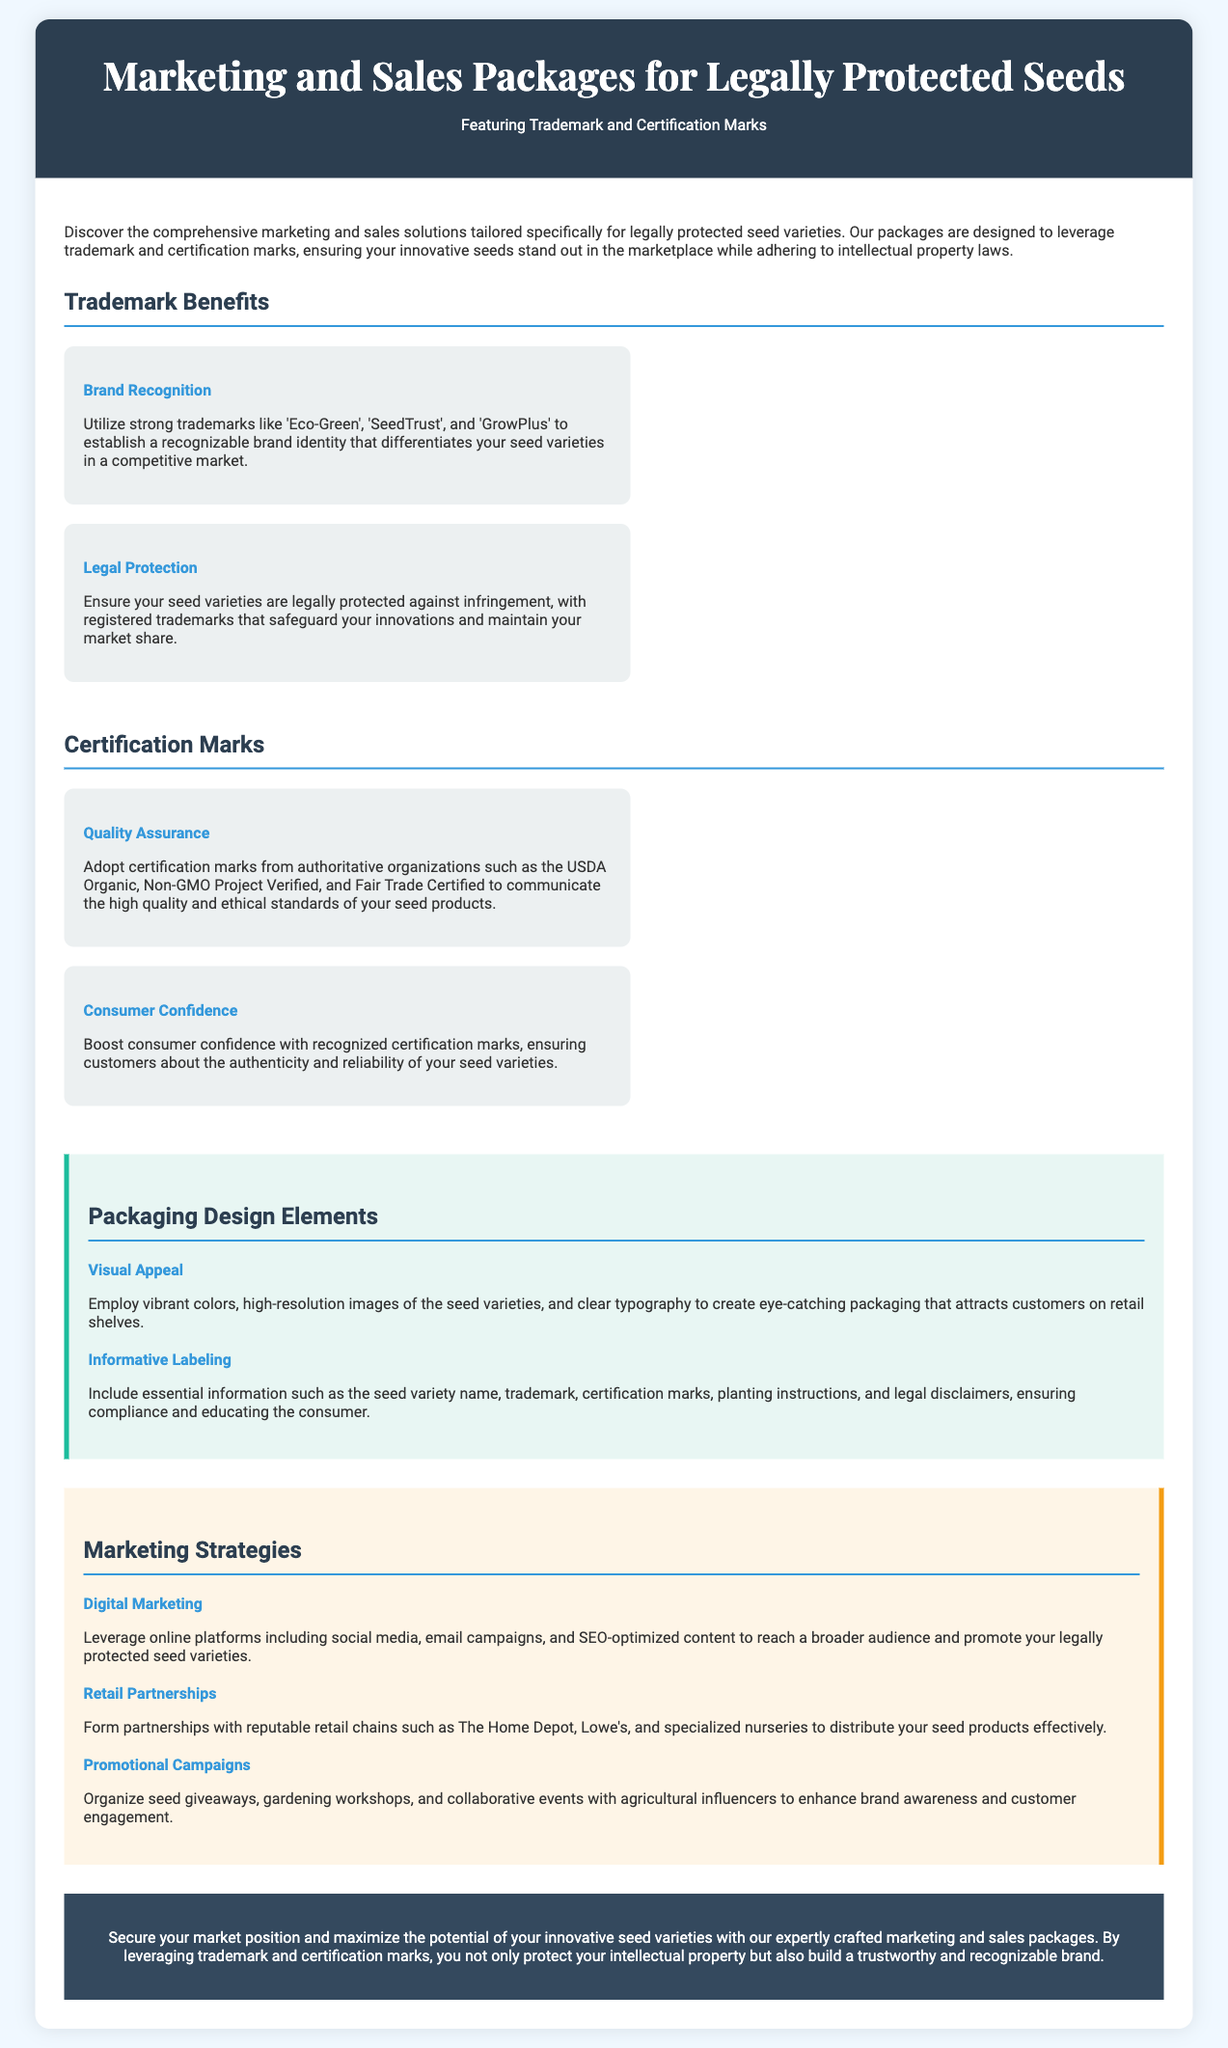What is the title of the document? The title of the document is presented in the header section, introducing the core topic of the document.
Answer: Marketing and Sales Packages for Legally Protected Seeds What are the names of three trademarks mentioned? The document lists specific trademarks under the Trademark Benefits section, highlighting their importance in branding.
Answer: Eco-Green, SeedTrust, GrowPlus What certification mark is associated with quality assurance? The document refers to specific certification marks that signify quality assurance for seed products in the Certification Marks section.
Answer: USDA Organic What is one key benefit of legal protection mentioned? Legal protection is discussed in the context of safeguarding seed varieties against infringement, ensuring market presence.
Answer: ensures your seed varieties are legally protected against infringement What is suggested as a marketing strategy? The document includes various strategies aimed at promoting the seeds, demonstrating ways to increase brand visibility.
Answer: Digital Marketing Which packaging design element focuses on consumer attraction? The packaging design elements include aspects that make the product appealing and attract customers' attention.
Answer: Visual Appeal How many benefits are listed under Trademark Benefits? The section titled Trademark Benefits presents specific advantages associated with utilizing trademarks for seed branding.
Answer: Two What are two examples of retail partners mentioned? The document lists specific retail chains in the context of partnerships aimed at effective distribution of seed products.
Answer: The Home Depot, Lowe's What theme is emphasized in the conclusion? The conclusion summarizes the benefits associated with marketing strategies and trademark usage, reinforcing the main message of the document.
Answer: Secure your market position 